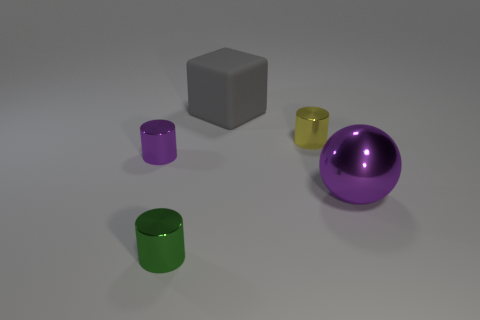Subtract all blue balls. Subtract all yellow blocks. How many balls are left? 1 Add 2 small yellow things. How many objects exist? 7 Subtract all blocks. How many objects are left? 4 Add 3 gray rubber cubes. How many gray rubber cubes are left? 4 Add 5 large purple objects. How many large purple objects exist? 6 Subtract 0 red cylinders. How many objects are left? 5 Subtract all rubber objects. Subtract all big purple balls. How many objects are left? 3 